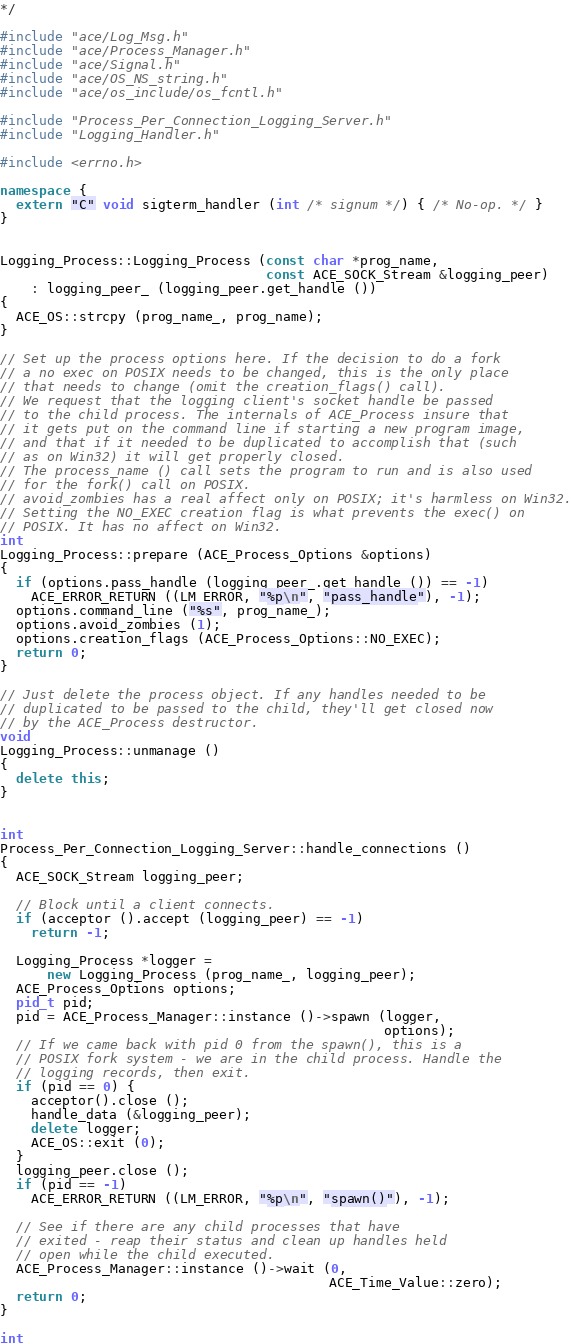Convert code to text. <code><loc_0><loc_0><loc_500><loc_500><_C++_>*/

#include "ace/Log_Msg.h"
#include "ace/Process_Manager.h"
#include "ace/Signal.h"
#include "ace/OS_NS_string.h"
#include "ace/os_include/os_fcntl.h"

#include "Process_Per_Connection_Logging_Server.h"
#include "Logging_Handler.h"

#include <errno.h>

namespace {
  extern "C" void sigterm_handler (int /* signum */) { /* No-op. */ }
}


Logging_Process::Logging_Process (const char *prog_name,
                                  const ACE_SOCK_Stream &logging_peer)
    : logging_peer_ (logging_peer.get_handle ())
{
  ACE_OS::strcpy (prog_name_, prog_name);
}

// Set up the process options here. If the decision to do a fork
// a no exec on POSIX needs to be changed, this is the only place
// that needs to change (omit the creation_flags() call).
// We request that the logging client's socket handle be passed
// to the child process. The internals of ACE_Process insure that
// it gets put on the command line if starting a new program image,
// and that if it needed to be duplicated to accomplish that (such
// as on Win32) it will get properly closed.
// The process_name () call sets the program to run and is also used
// for the fork() call on POSIX.
// avoid_zombies has a real affect only on POSIX; it's harmless on Win32.
// Setting the NO_EXEC creation flag is what prevents the exec() on
// POSIX. It has no affect on Win32.
int
Logging_Process::prepare (ACE_Process_Options &options)
{
  if (options.pass_handle (logging_peer_.get_handle ()) == -1)
    ACE_ERROR_RETURN ((LM_ERROR, "%p\n", "pass_handle"), -1);
  options.command_line ("%s", prog_name_);
  options.avoid_zombies (1);
  options.creation_flags (ACE_Process_Options::NO_EXEC);
  return 0;
}

// Just delete the process object. If any handles needed to be
// duplicated to be passed to the child, they'll get closed now
// by the ACE_Process destructor.
void
Logging_Process::unmanage ()
{
  delete this;
}


int
Process_Per_Connection_Logging_Server::handle_connections ()
{
  ACE_SOCK_Stream logging_peer;

  // Block until a client connects.
  if (acceptor ().accept (logging_peer) == -1)
    return -1;

  Logging_Process *logger =
      new Logging_Process (prog_name_, logging_peer);
  ACE_Process_Options options;
  pid_t pid;
  pid = ACE_Process_Manager::instance ()->spawn (logger,
                                                 options);
  // If we came back with pid 0 from the spawn(), this is a
  // POSIX fork system - we are in the child process. Handle the
  // logging records, then exit.
  if (pid == 0) {
    acceptor().close ();
    handle_data (&logging_peer);
    delete logger;
    ACE_OS::exit (0);
  }
  logging_peer.close ();
  if (pid == -1)
    ACE_ERROR_RETURN ((LM_ERROR, "%p\n", "spawn()"), -1);

  // See if there are any child processes that have
  // exited - reap their status and clean up handles held
  // open while the child executed.
  ACE_Process_Manager::instance ()->wait (0,
                                          ACE_Time_Value::zero);
  return 0;
}

int</code> 